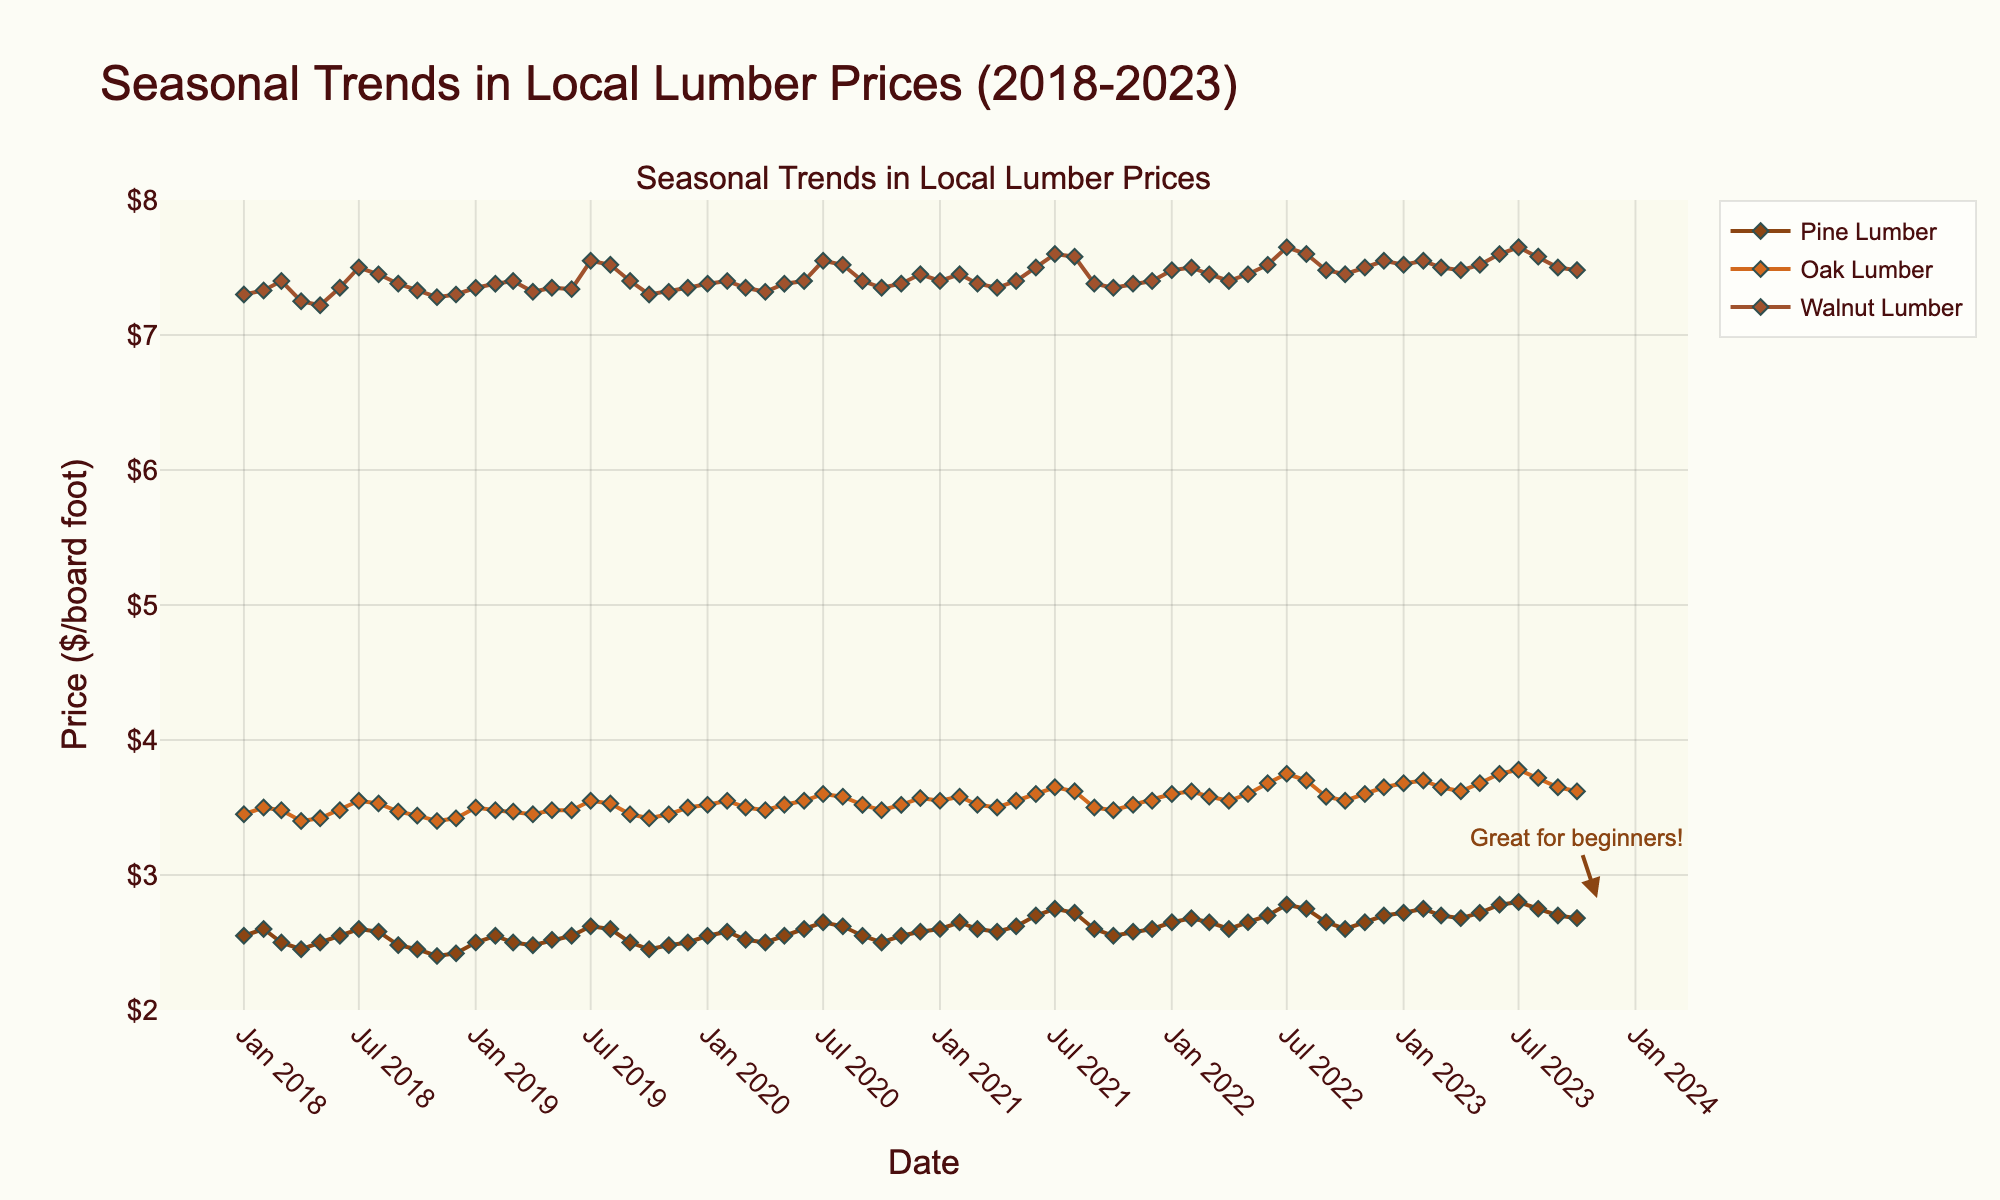What is the title of the plot? The title is usually located at the top of the figure in larger and bold text. From the description, the title in this plot is "Seasonal Trends in Local Lumber Prices (2018-2023)."
Answer: Seasonal Trends in Local Lumber Prices (2018-2023) What is the price range displayed on the y-axis? The y-axis ranges from $2 to $8, covering the prices of all types of lumber displayed on the plot.
Answer: $2 to $8 Which type of lumber shows the highest price in July 2023? From the figure, we observe the data points for July 2023. Walnut lumber has the highest price among Pine, Oak, and Walnut in July 2023.
Answer: Walnut How do the prices of Pine, Oak, and Walnut lumber compare in January 2018? We look at the data points corresponding to January 2018 for Pine, Oak, and Walnut. Pine: $2.55, Oak: $3.45, and Walnut: $7.30. Walnut is the highest, followed by Oak and then Pine.
Answer: Walnut > Oak > Pine Is there any significant seasonal trend in the price of Walnut lumber? By observing the line representing Walnut lumber, it varies over the months with some fluctuations but generally has a stable trend with slight increases in summer months (June to August).
Answer: Slight rise in summer How much did the price of Pine lumber increase from April 2020 to July 2022? Check the data points for Pine lumber in April 2020 ($2.50) and July 2022 ($2.78). Calculate the difference: $2.78 - $2.50 = $0.28.
Answer: $0.28 Which lumber type has the least variation in price from 2018 to 2023? Compare the fluctuations in the lines for Pine, Oak, and Walnut lumber. Pine appears to have the least variation as its price exhibits the smallest changes over time.
Answer: Pine During which months does Oak lumber see noticeable price increases each year? By observing Oak's line trend, noticeable price increases typically appear from June to August each year.
Answer: June to August What is the average price of Walnut lumber in the year 2022? Look at the Walnut prices for all months in 2022: January ($7.48), February ($7.50), March ($7.45), April ($7.40), May ($7.45), June ($7.52), July ($7.65), August ($7.60), September ($7.48), October ($7.45), November ($7.50), December ($7.55). Sum these values and divide by 12. (7.48 + 7.50 + 7.45 + 7.40 + 7.45 + 7.52 + 7.65 + 7.60 + 7.48 + 7.45 + 7.50 + 7.55) / 12 = 7.51.
Answer: $7.51 How does the price of Oak lumber in October 2023 compare to its price in February 2018? Check the data points for Oak in October 2023 ($3.62) and February 2018 ($3.50). Calculate the difference: $3.62 - $3.50 = $0.12.
Answer: $0.12 higher 